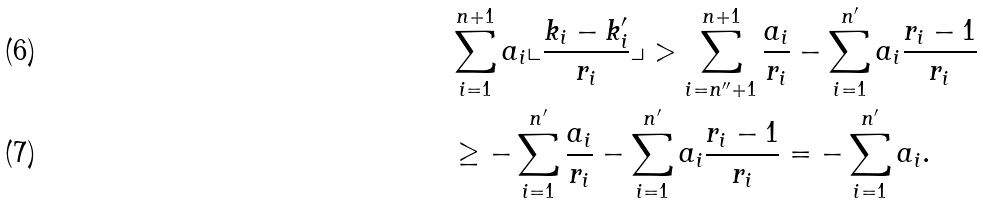<formula> <loc_0><loc_0><loc_500><loc_500>& \sum _ { i = 1 } ^ { n + 1 } a _ { i } \llcorner \frac { k _ { i } - k ^ { \prime } _ { i } } { r _ { i } } \lrcorner > \sum _ { i = n ^ { \prime \prime } + 1 } ^ { n + 1 } \frac { a _ { i } } { r _ { i } } - \sum _ { i = 1 } ^ { n ^ { \prime } } a _ { i } \frac { r _ { i } - 1 } { r _ { i } } \\ & \geq - \sum _ { i = 1 } ^ { n ^ { \prime } } \frac { a _ { i } } { r _ { i } } - \sum _ { i = 1 } ^ { n ^ { \prime } } a _ { i } \frac { r _ { i } - 1 } { r _ { i } } = - \sum _ { i = 1 } ^ { n ^ { \prime } } a _ { i } .</formula> 